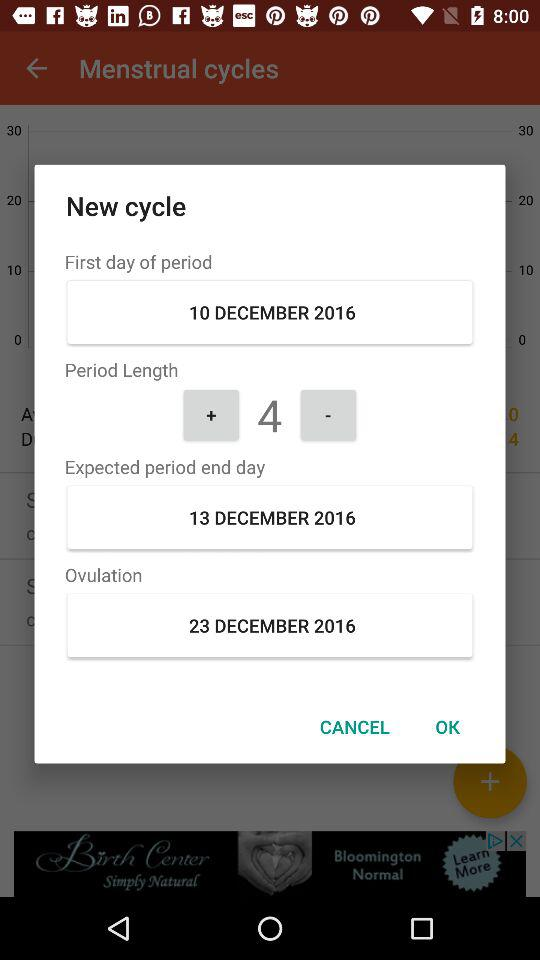What is the date of the first day of the period? The date is December 10, 2016. 